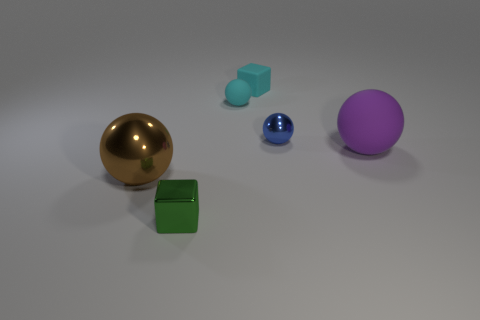There is a metal object behind the matte thing that is in front of the blue object to the left of the purple thing; what is its shape?
Give a very brief answer. Sphere. What number of other objects are the same shape as the brown thing?
Your answer should be very brief. 3. There is a small thing on the left side of the rubber ball that is behind the big purple thing; what is it made of?
Offer a very short reply. Metal. Is there anything else that has the same size as the blue sphere?
Your answer should be very brief. Yes. Do the big brown sphere and the big sphere on the right side of the green object have the same material?
Make the answer very short. No. What material is the sphere that is on the right side of the big brown metallic sphere and in front of the blue sphere?
Offer a terse response. Rubber. What color is the metal sphere that is on the left side of the cyan block behind the large shiny sphere?
Offer a very short reply. Brown. What is the block in front of the purple rubber thing made of?
Provide a short and direct response. Metal. Is the number of green metallic things less than the number of gray shiny objects?
Keep it short and to the point. No. Does the green object have the same shape as the metal object that is behind the large purple object?
Provide a succinct answer. No. 